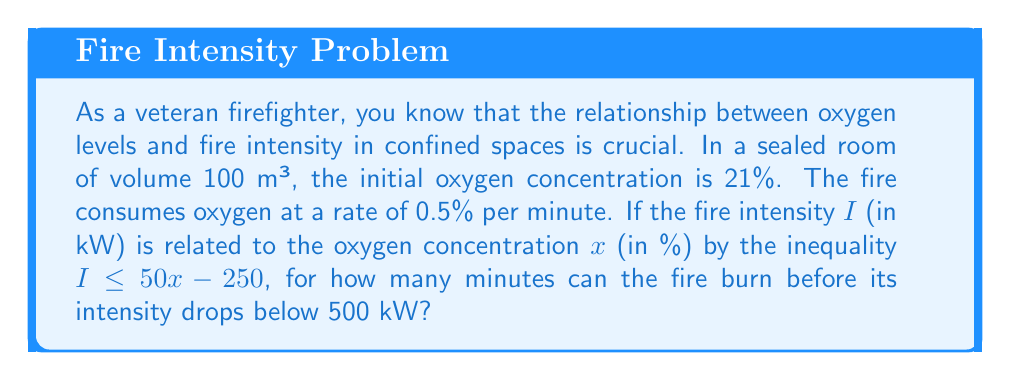What is the answer to this math problem? Let's approach this step-by-step:

1) First, we need to establish the relationship between time and oxygen concentration:
   Initial concentration: 21%
   Rate of consumption: 0.5% per minute
   
   After $t$ minutes, the oxygen concentration $x$ will be:
   $x = 21 - 0.5t$

2) Now, we need to find when the fire intensity drops below 500 kW. We can use the given inequality:
   $I \leq 50x - 250$
   
   At the point where $I = 500$:
   $500 = 50x - 250$

3) Solve this equation for $x$:
   $750 = 50x$
   $x = 15\%$

4) Now we know that when the oxygen concentration reaches 15%, the fire intensity will be 500 kW.

5) Let's use our equation from step 1 to find when this occurs:
   $15 = 21 - 0.5t$
   $-6 = -0.5t$
   $t = 12$

Therefore, after 12 minutes, the oxygen concentration will be 15%, and the fire intensity will drop to 500 kW.

6) To verify, we can check the inequality:
   At $t = 12$, $x = 15\%$
   $I \leq 50(15) - 250 = 500$

   This confirms our result.
Answer: The fire can burn for 12 minutes before its intensity drops below 500 kW. 